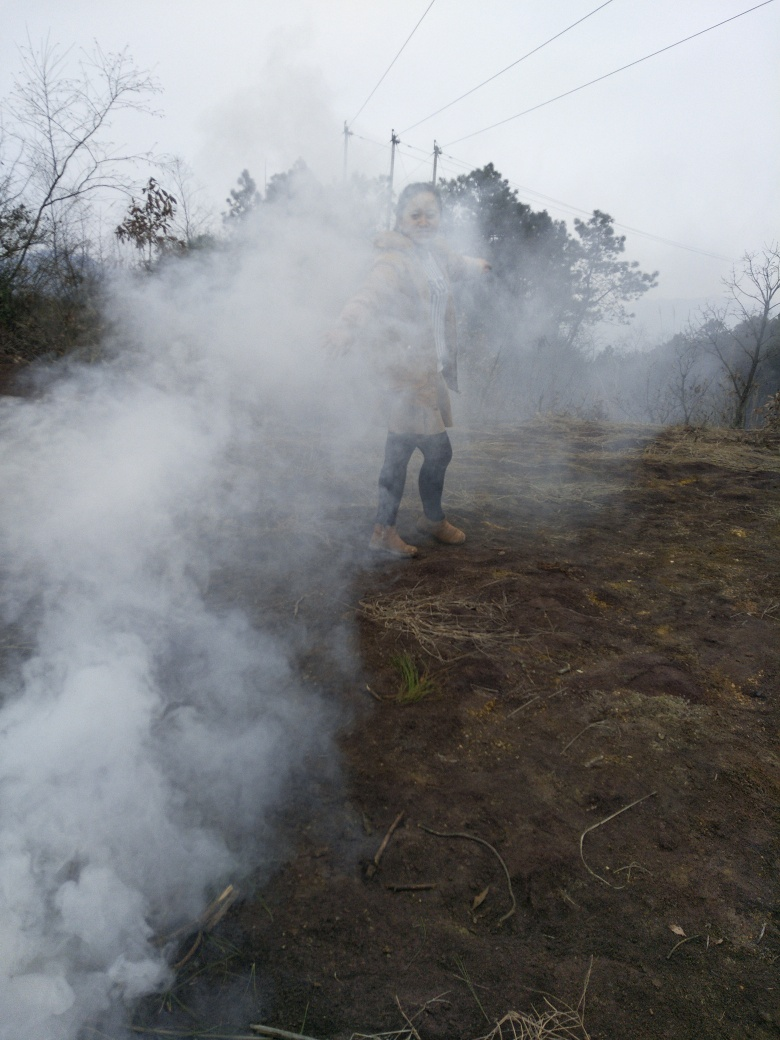Is the area depicted in the image commonly associated with fires or smoke? Please provide a general observation. Without specific knowledge of the location, general observations suggest an outdoor rural or wilderness area. Such spaces can be prone to fires, whether natural, accidental, or deliberate for management purposes. The sparse vegetation and the soil suggest a non-urban setting but one that does not appear particularly lush or verdant, potentially indicating a place where controlled burns may be part of land management practices or where natural fires may occasionally occur. 